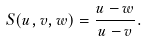<formula> <loc_0><loc_0><loc_500><loc_500>S ( u , v , w ) = { \frac { u - w } { u - v } } .</formula> 